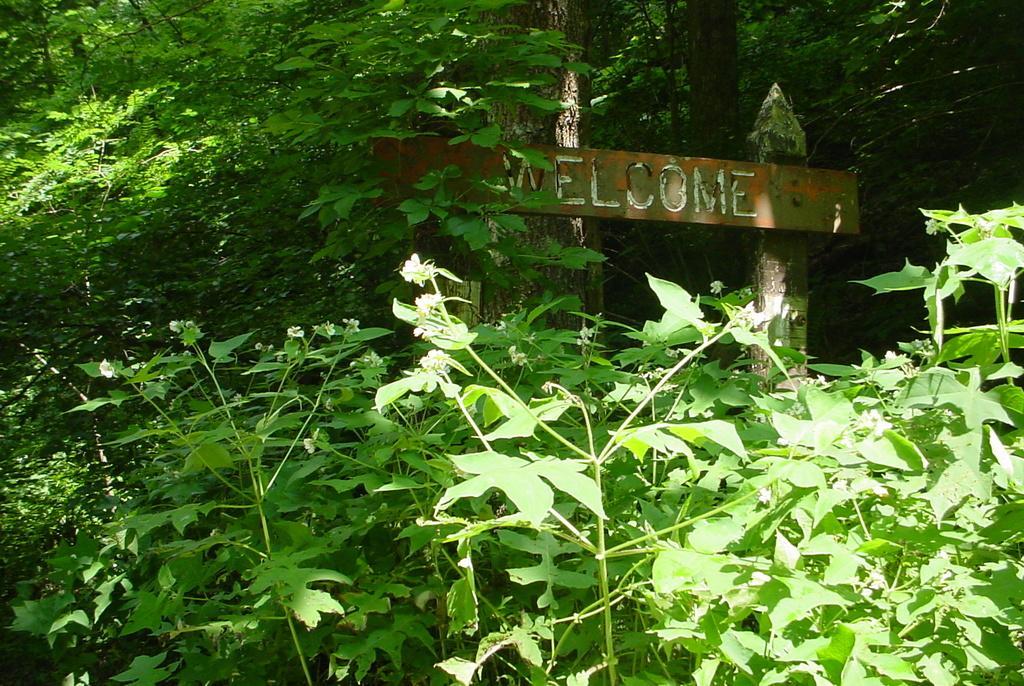In one or two sentences, can you explain what this image depicts? In this image I can see plants and trees in green color. Background I can see an arch. 